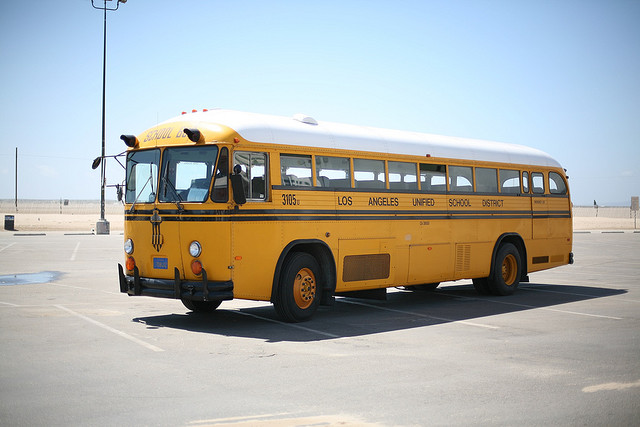Please transcribe the text information in this image. DISTRICT 3105 LOS ANGELES UNIFIED SCHOOL 